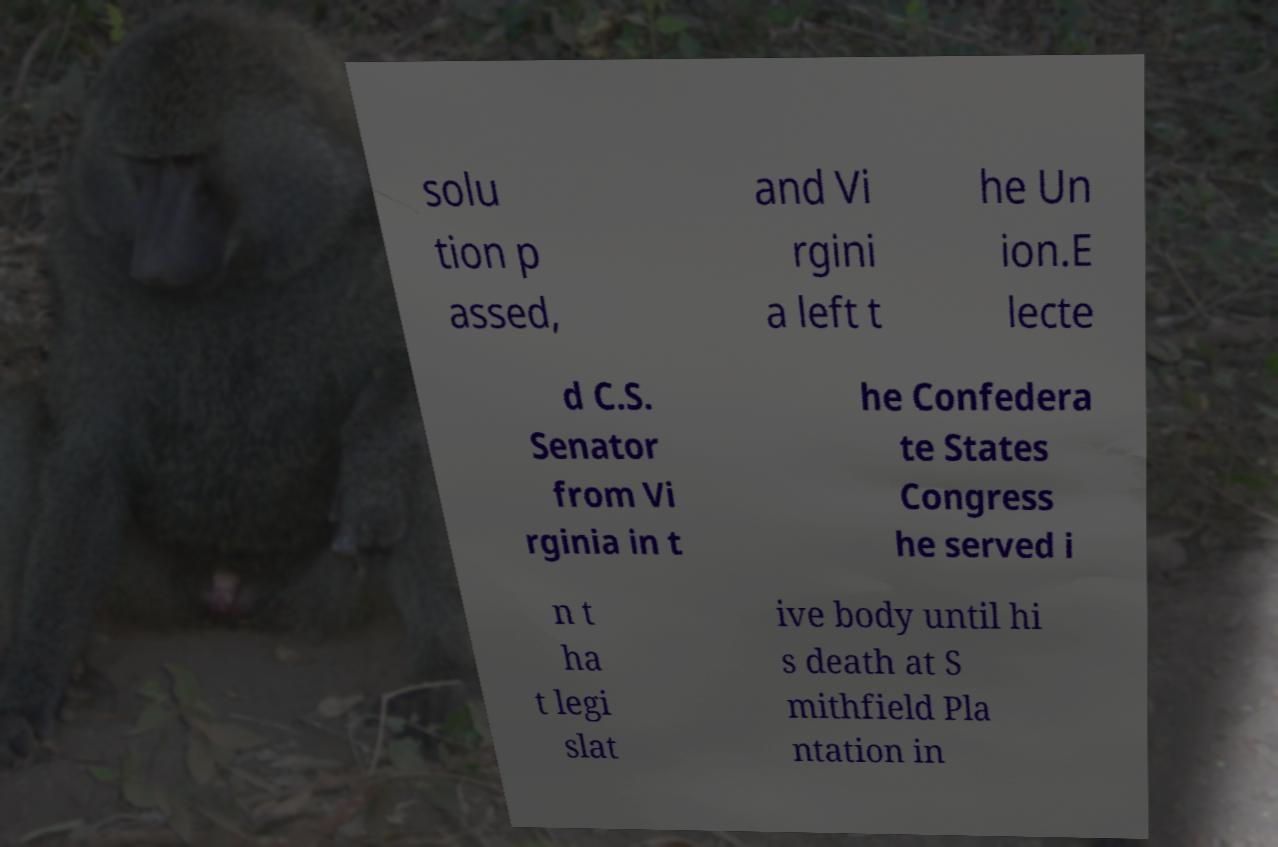There's text embedded in this image that I need extracted. Can you transcribe it verbatim? solu tion p assed, and Vi rgini a left t he Un ion.E lecte d C.S. Senator from Vi rginia in t he Confedera te States Congress he served i n t ha t legi slat ive body until hi s death at S mithfield Pla ntation in 